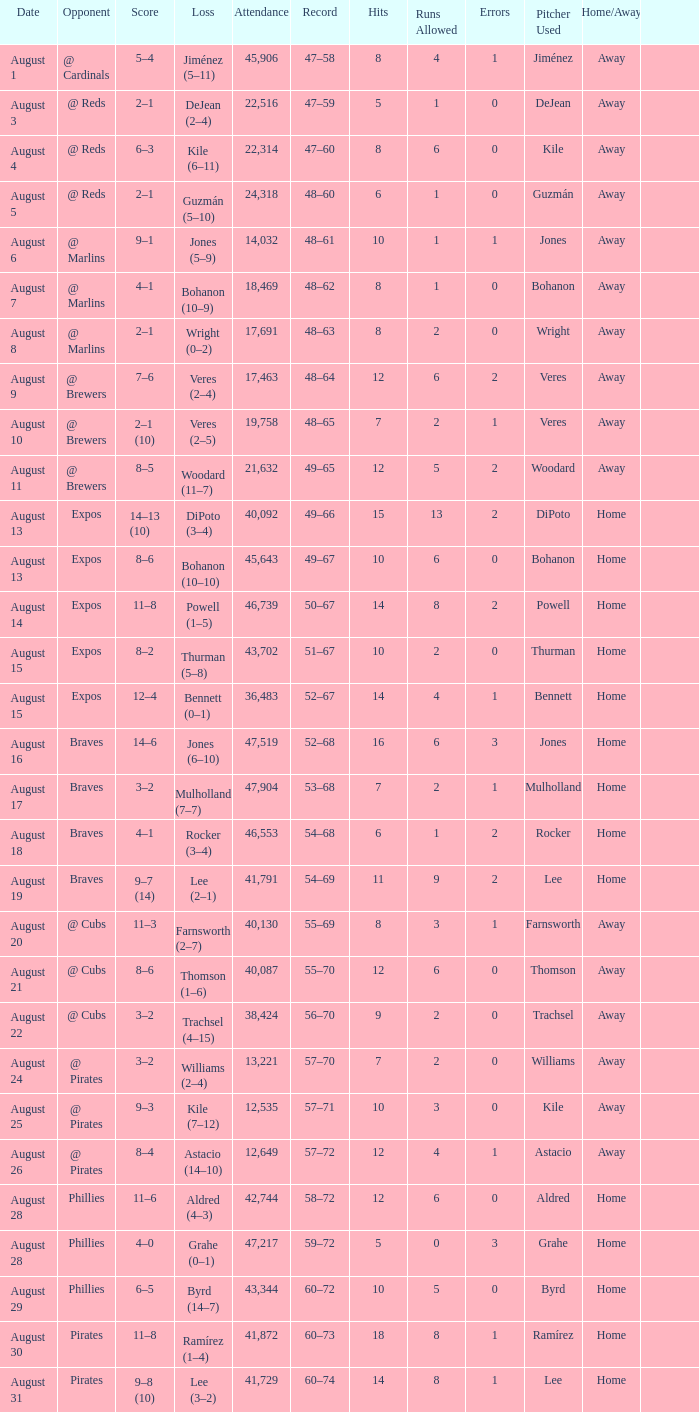What is the lowest attendance total on August 26? 12649.0. 